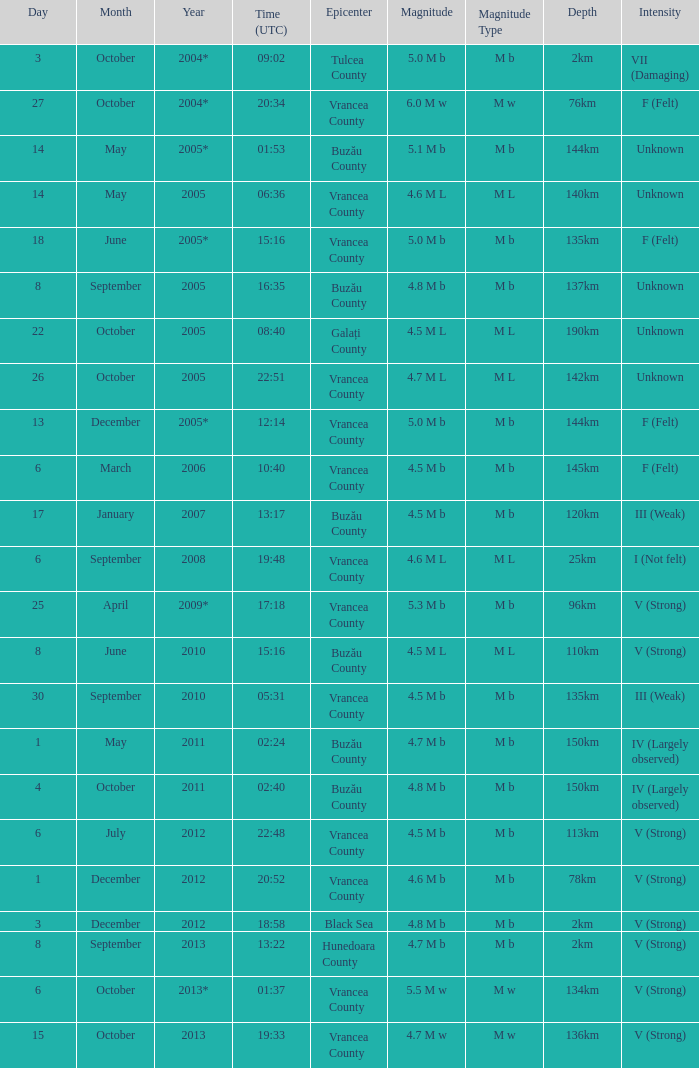What is the magnitude with epicenter at Vrancea County, unknown intensity and which happened at 06:36? 4.6 M L. 